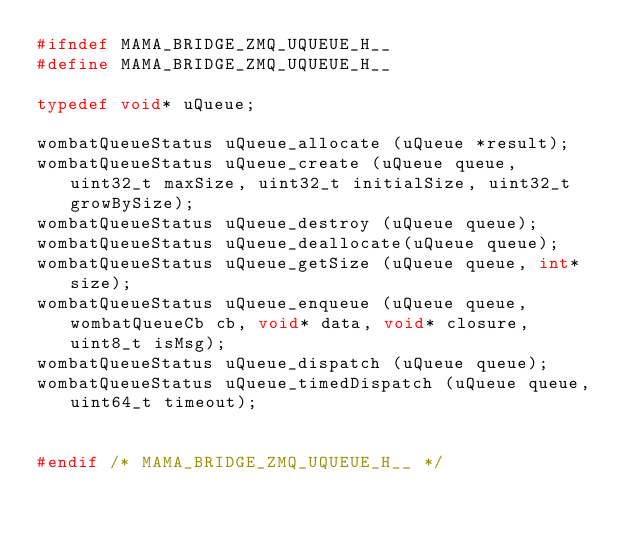Convert code to text. <code><loc_0><loc_0><loc_500><loc_500><_C_>#ifndef MAMA_BRIDGE_ZMQ_UQUEUE_H__
#define MAMA_BRIDGE_ZMQ_UQUEUE_H__

typedef void* uQueue;

wombatQueueStatus uQueue_allocate (uQueue *result);
wombatQueueStatus uQueue_create (uQueue queue, uint32_t maxSize, uint32_t initialSize, uint32_t growBySize);
wombatQueueStatus uQueue_destroy (uQueue queue);
wombatQueueStatus uQueue_deallocate(uQueue queue);
wombatQueueStatus uQueue_getSize (uQueue queue, int* size);
wombatQueueStatus uQueue_enqueue (uQueue queue, wombatQueueCb cb, void* data, void* closure, uint8_t isMsg);
wombatQueueStatus uQueue_dispatch (uQueue queue);
wombatQueueStatus uQueue_timedDispatch (uQueue queue, uint64_t timeout);


#endif /* MAMA_BRIDGE_ZMQ_UQUEUE_H__ */</code> 